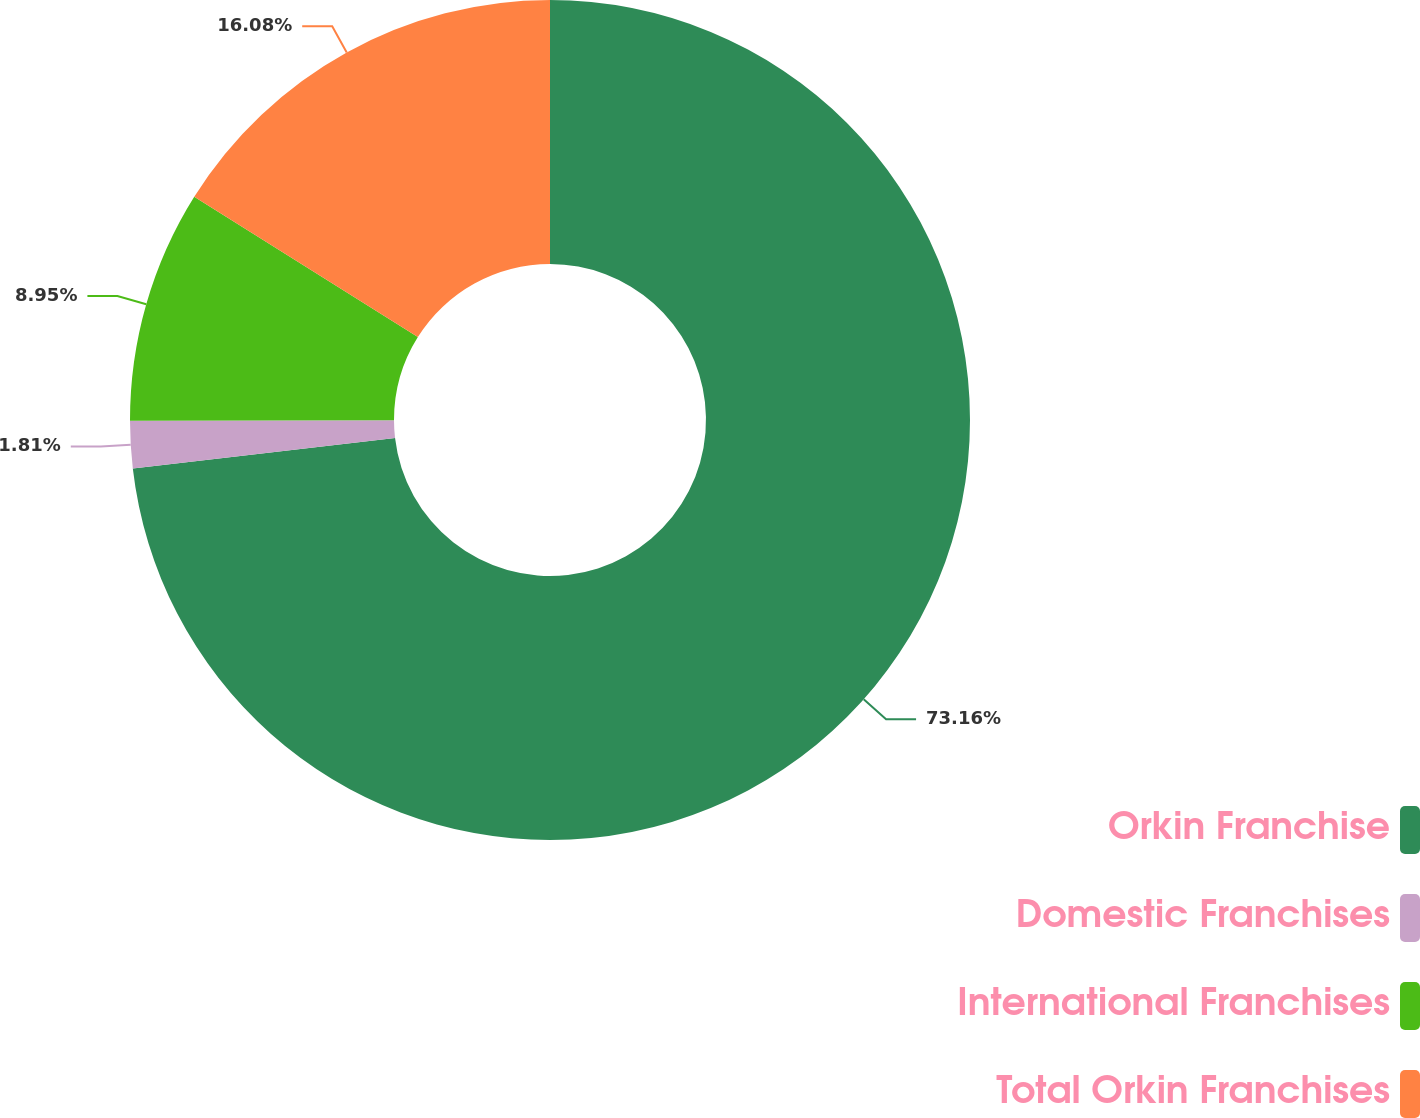<chart> <loc_0><loc_0><loc_500><loc_500><pie_chart><fcel>Orkin Franchise<fcel>Domestic Franchises<fcel>International Franchises<fcel>Total Orkin Franchises<nl><fcel>73.15%<fcel>1.81%<fcel>8.95%<fcel>16.08%<nl></chart> 